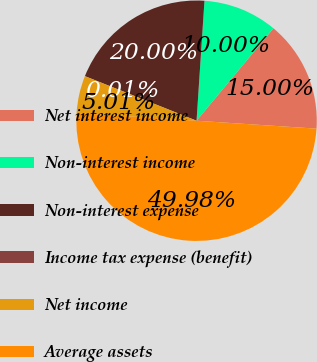Convert chart. <chart><loc_0><loc_0><loc_500><loc_500><pie_chart><fcel>Net interest income<fcel>Non-interest income<fcel>Non-interest expense<fcel>Income tax expense (benefit)<fcel>Net income<fcel>Average assets<nl><fcel>15.0%<fcel>10.0%<fcel>20.0%<fcel>0.01%<fcel>5.01%<fcel>49.98%<nl></chart> 